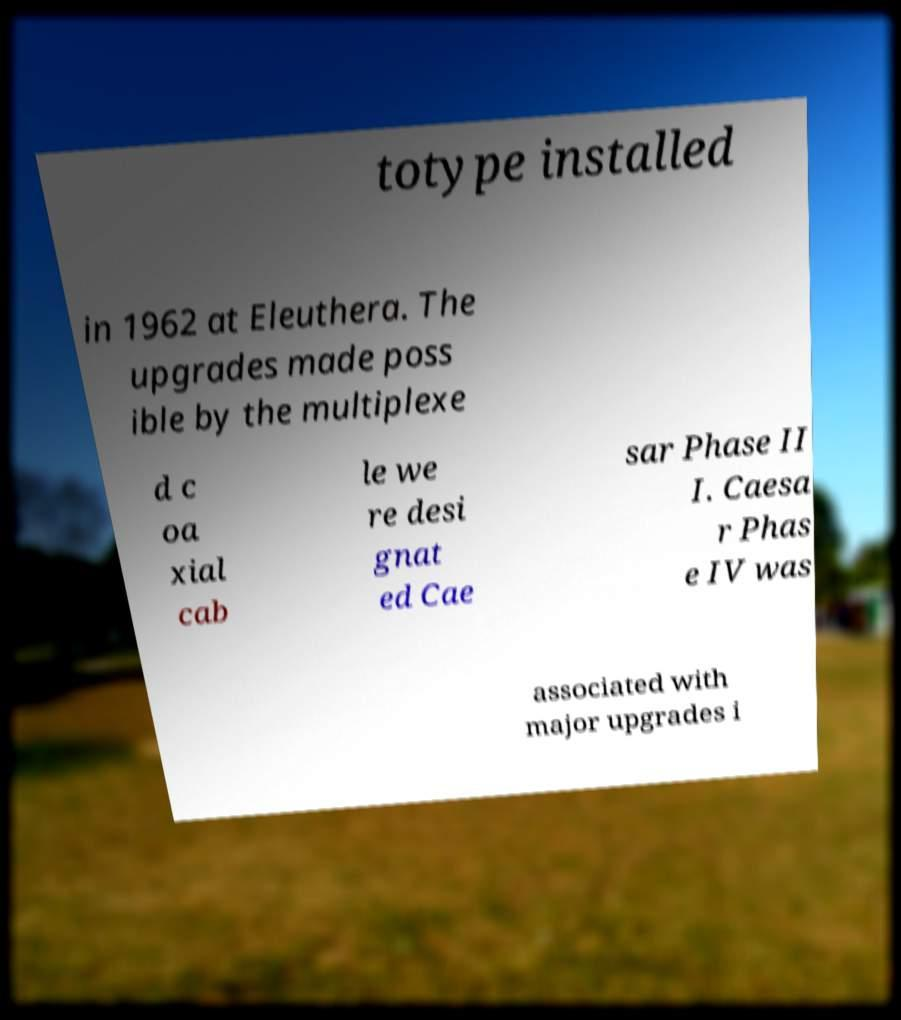Please read and relay the text visible in this image. What does it say? totype installed in 1962 at Eleuthera. The upgrades made poss ible by the multiplexe d c oa xial cab le we re desi gnat ed Cae sar Phase II I. Caesa r Phas e IV was associated with major upgrades i 